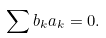Convert formula to latex. <formula><loc_0><loc_0><loc_500><loc_500>\sum b _ { k } a _ { k } = 0 .</formula> 